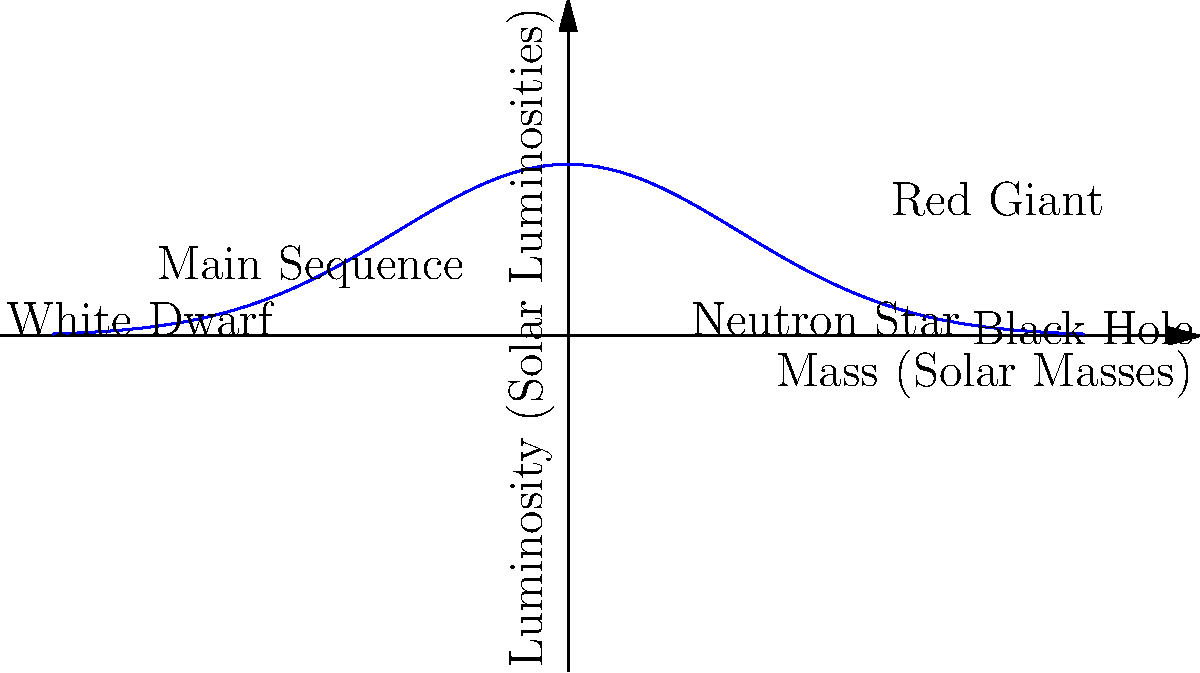Considering the Hertzsprung-Russell diagram shown above, which represents the life cycle of stars, critically analyze why the majority of stars, including our Sun, spend most of their lives on the Main Sequence. How does this relate to the concept of stellar equilibrium, and what factors determine a star's eventual fate? To answer this question, let's break it down step-by-step:

1. Main Sequence stars:
   - The Main Sequence is where stars spend most of their lives.
   - This is due to a state of hydrostatic equilibrium.

2. Stellar equilibrium:
   - Gravity pulls inward, trying to collapse the star.
   - Outward pressure from nuclear fusion counteracts gravity.
   - This balance keeps stars stable for billions of years.

3. Factors determining a star's fate:
   a) Initial mass:
      - More massive stars burn fuel faster and have shorter lifespans.
      - Less massive stars burn slower and live longer.
   
   b) Composition:
      - Stars with higher metallicity have different evolutionary paths.

4. Post-Main Sequence evolution:
   - Low-mass stars (< 8 solar masses) become Red Giants, then White Dwarfs.
   - Intermediate-mass stars (8-20 solar masses) become Neutron Stars.
   - High-mass stars (> 20 solar masses) become Black Holes.

5. Critical analysis:
   - The long Main Sequence lifetime allows for the development of complex life on planets.
   - Understanding stellar evolution helps in estimating the age of the universe and galaxies.
   - The fate of stars impacts the chemical enrichment of the universe, affecting future star formation.

This diagram and analysis demonstrate the complex interplay of physics in stellar evolution, highlighting the importance of initial conditions in determining a star's life cycle.
Answer: Stars spend most of their lives on the Main Sequence due to hydrostatic equilibrium between gravity and fusion pressure. Initial mass and composition determine their eventual fate as White Dwarfs, Neutron Stars, or Black Holes. 